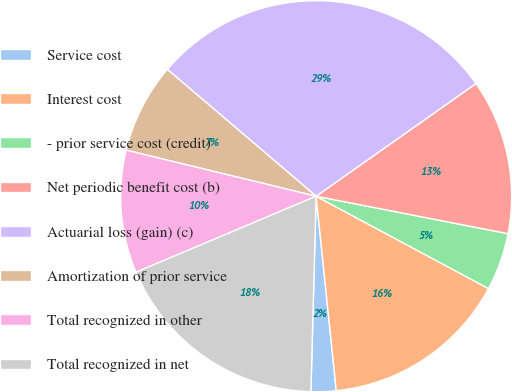Convert chart. <chart><loc_0><loc_0><loc_500><loc_500><pie_chart><fcel>Service cost<fcel>Interest cost<fcel>- prior service cost (credit)<fcel>Net periodic benefit cost (b)<fcel>Actuarial loss (gain) (c)<fcel>Amortization of prior service<fcel>Total recognized in other<fcel>Total recognized in net<nl><fcel>2.07%<fcel>15.53%<fcel>4.76%<fcel>12.84%<fcel>28.99%<fcel>7.45%<fcel>10.14%<fcel>18.22%<nl></chart> 